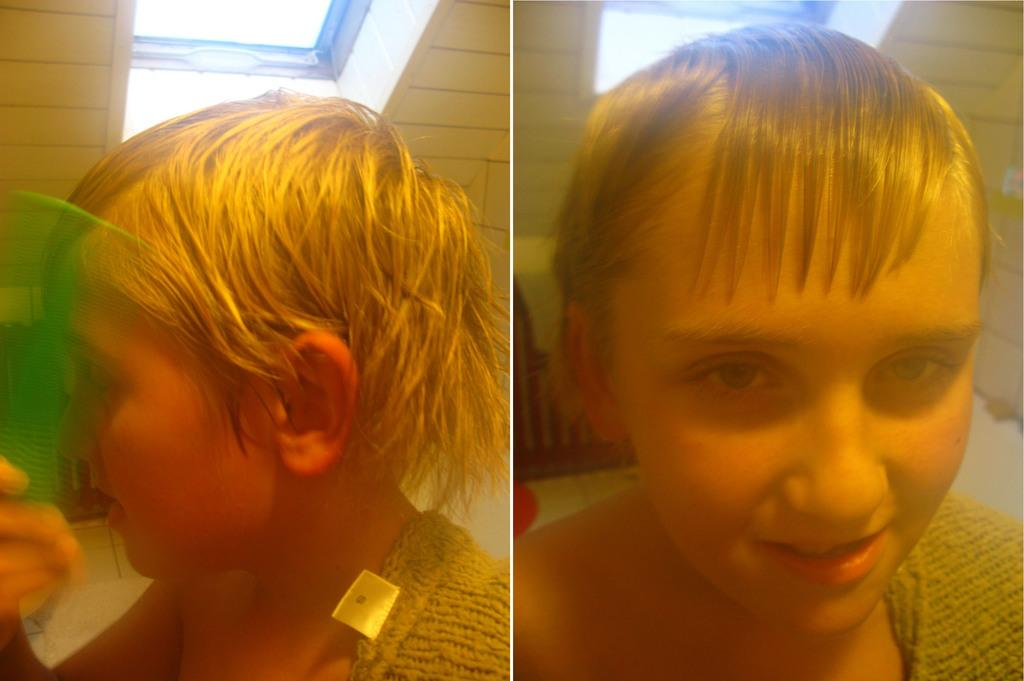What type of artwork is the image? The image is a collage. What can be seen in the collage? There is a kid in the image. Where is the house located in the image? There is no house present in the image; it is a collage featuring a kid. What type of plants can be seen in the garden in the image? There is no garden present in the image, as it is a collage featuring a kid. 